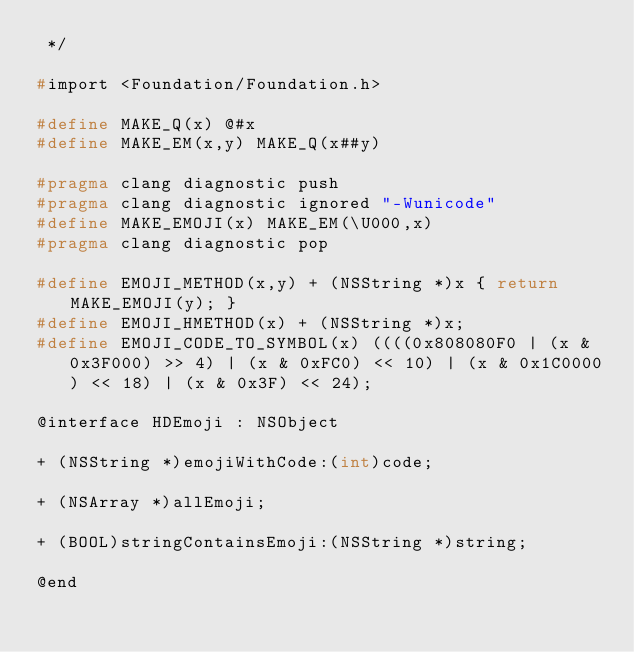Convert code to text. <code><loc_0><loc_0><loc_500><loc_500><_C_> */

#import <Foundation/Foundation.h>

#define MAKE_Q(x) @#x
#define MAKE_EM(x,y) MAKE_Q(x##y)

#pragma clang diagnostic push
#pragma clang diagnostic ignored "-Wunicode"
#define MAKE_EMOJI(x) MAKE_EM(\U000,x)
#pragma clang diagnostic pop

#define EMOJI_METHOD(x,y) + (NSString *)x { return MAKE_EMOJI(y); }
#define EMOJI_HMETHOD(x) + (NSString *)x;
#define EMOJI_CODE_TO_SYMBOL(x) ((((0x808080F0 | (x & 0x3F000) >> 4) | (x & 0xFC0) << 10) | (x & 0x1C0000) << 18) | (x & 0x3F) << 24);

@interface HDEmoji : NSObject

+ (NSString *)emojiWithCode:(int)code;

+ (NSArray *)allEmoji;

+ (BOOL)stringContainsEmoji:(NSString *)string;

@end
</code> 